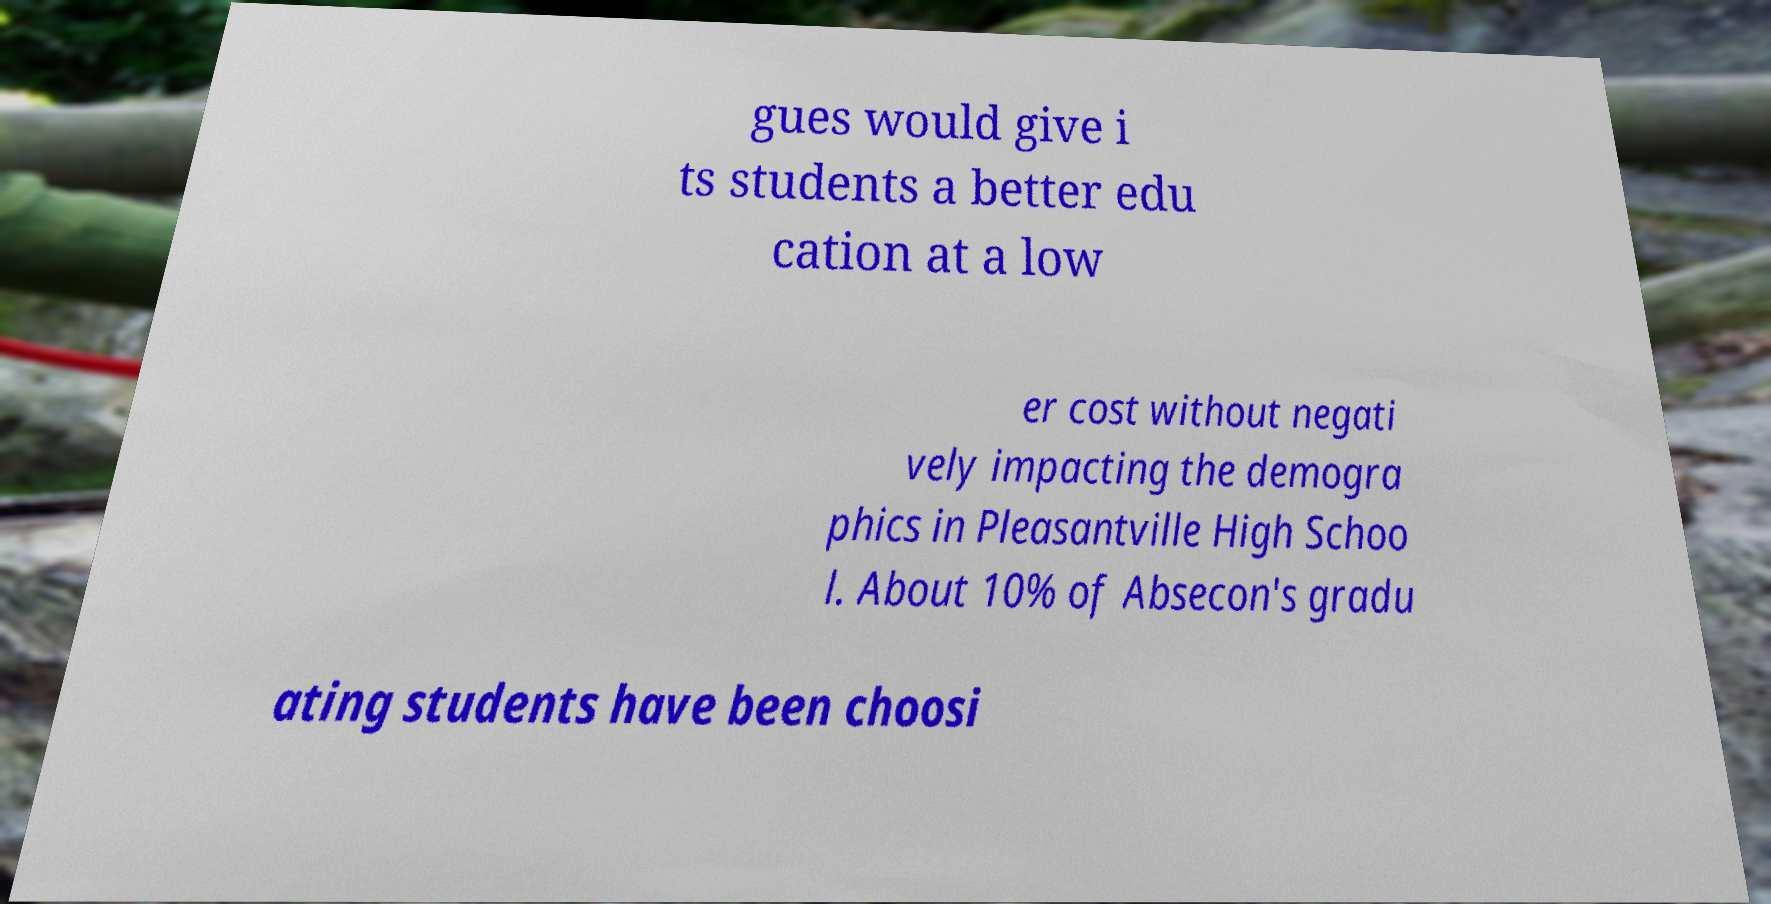I need the written content from this picture converted into text. Can you do that? gues would give i ts students a better edu cation at a low er cost without negati vely impacting the demogra phics in Pleasantville High Schoo l. About 10% of Absecon's gradu ating students have been choosi 